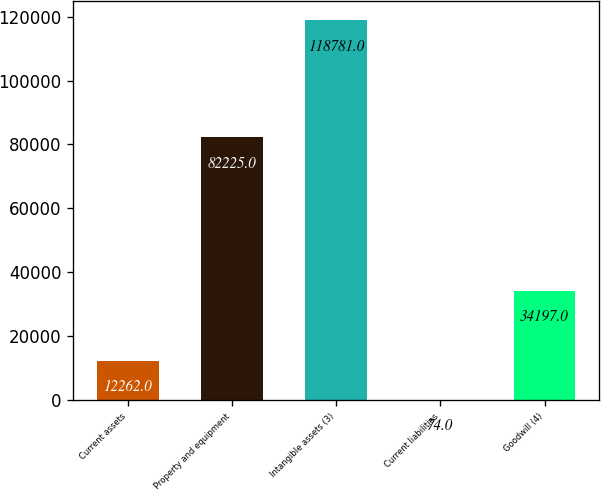<chart> <loc_0><loc_0><loc_500><loc_500><bar_chart><fcel>Current assets<fcel>Property and equipment<fcel>Intangible assets (3)<fcel>Current liabilities<fcel>Goodwill (4)<nl><fcel>12262<fcel>82225<fcel>118781<fcel>74<fcel>34197<nl></chart> 